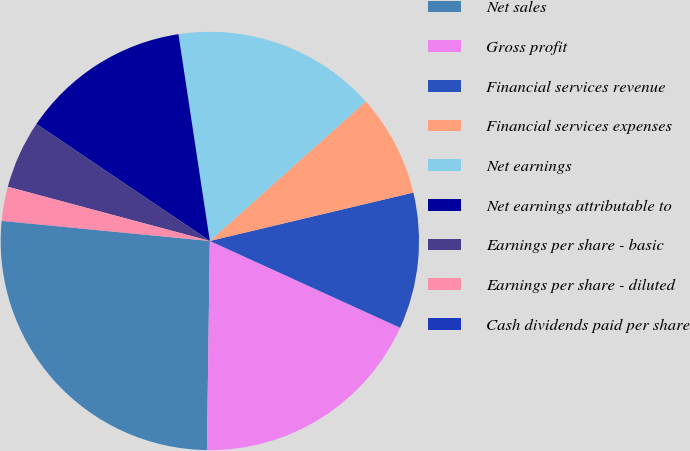Convert chart. <chart><loc_0><loc_0><loc_500><loc_500><pie_chart><fcel>Net sales<fcel>Gross profit<fcel>Financial services revenue<fcel>Financial services expenses<fcel>Net earnings<fcel>Net earnings attributable to<fcel>Earnings per share - basic<fcel>Earnings per share - diluted<fcel>Cash dividends paid per share<nl><fcel>26.3%<fcel>18.41%<fcel>10.53%<fcel>7.9%<fcel>15.78%<fcel>13.16%<fcel>5.27%<fcel>2.64%<fcel>0.01%<nl></chart> 